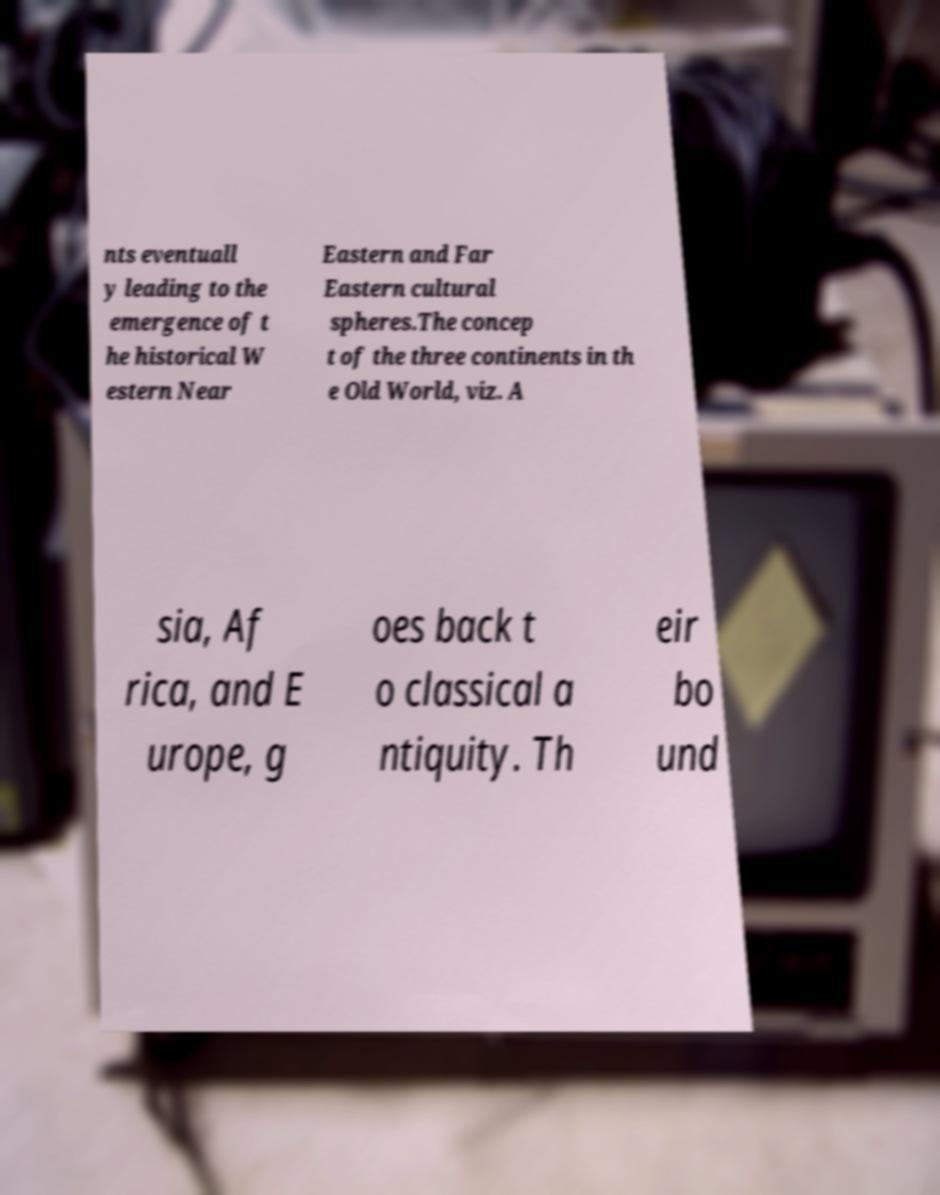Can you read and provide the text displayed in the image?This photo seems to have some interesting text. Can you extract and type it out for me? nts eventuall y leading to the emergence of t he historical W estern Near Eastern and Far Eastern cultural spheres.The concep t of the three continents in th e Old World, viz. A sia, Af rica, and E urope, g oes back t o classical a ntiquity. Th eir bo und 